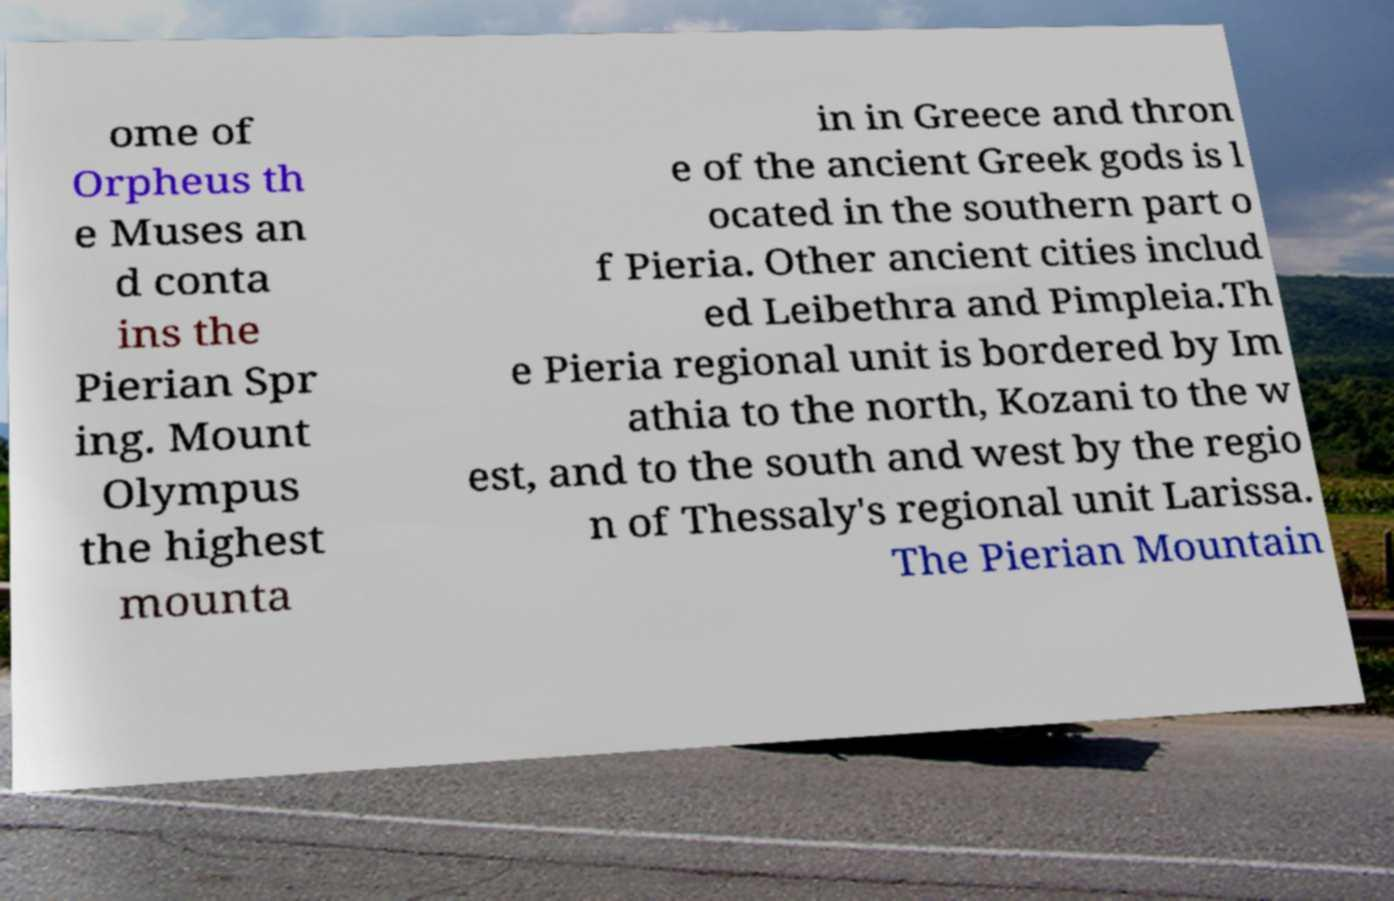What messages or text are displayed in this image? I need them in a readable, typed format. ome of Orpheus th e Muses an d conta ins the Pierian Spr ing. Mount Olympus the highest mounta in in Greece and thron e of the ancient Greek gods is l ocated in the southern part o f Pieria. Other ancient cities includ ed Leibethra and Pimpleia.Th e Pieria regional unit is bordered by Im athia to the north, Kozani to the w est, and to the south and west by the regio n of Thessaly's regional unit Larissa. The Pierian Mountain 